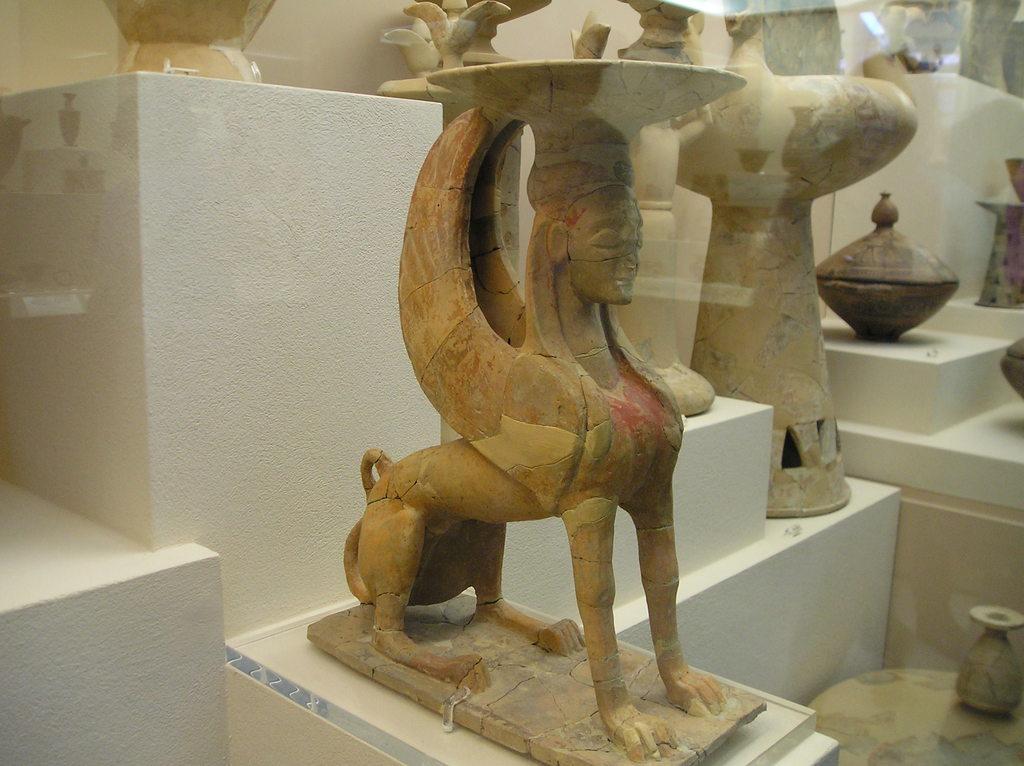Could you give a brief overview of what you see in this image? In this image I can see few statues on the white color concert-walls. 